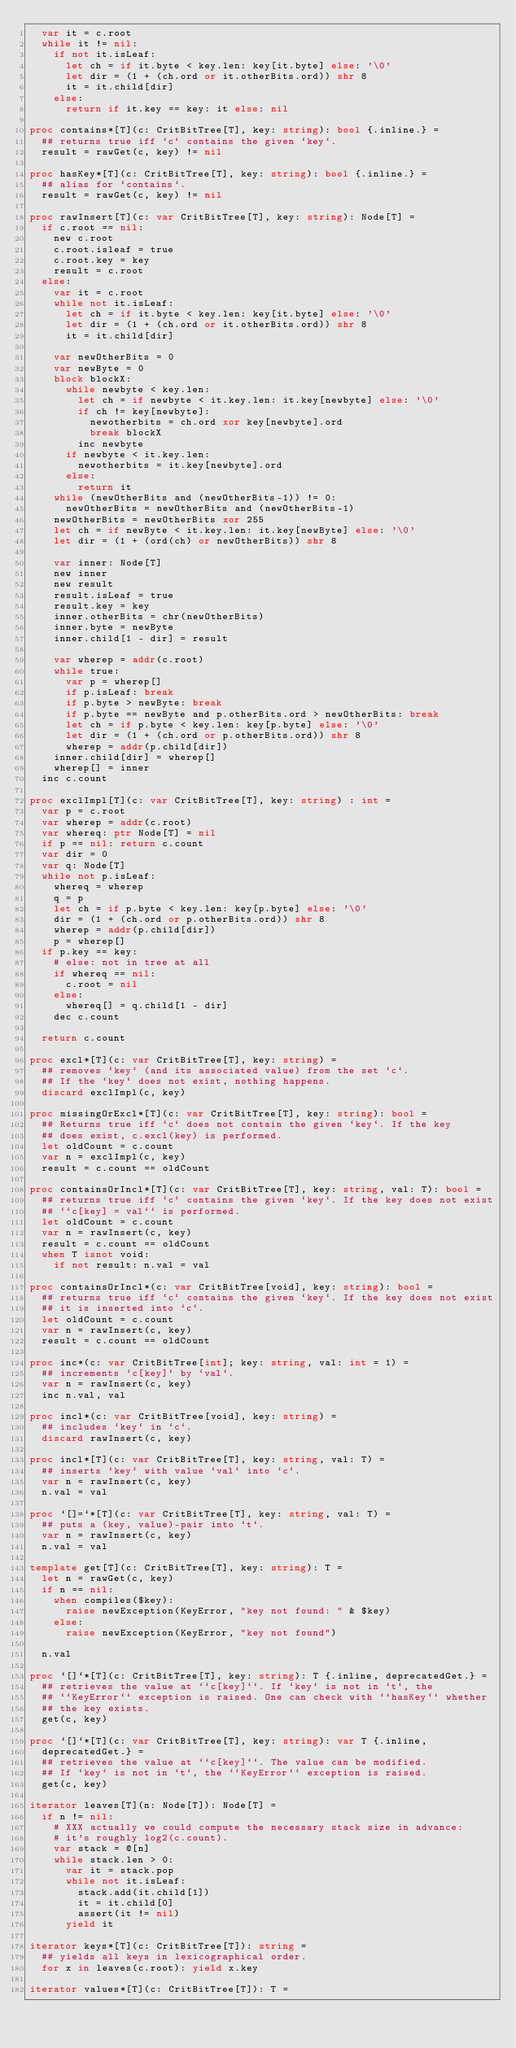<code> <loc_0><loc_0><loc_500><loc_500><_Nim_>  var it = c.root
  while it != nil:
    if not it.isLeaf:
      let ch = if it.byte < key.len: key[it.byte] else: '\0'
      let dir = (1 + (ch.ord or it.otherBits.ord)) shr 8
      it = it.child[dir]
    else:
      return if it.key == key: it else: nil

proc contains*[T](c: CritBitTree[T], key: string): bool {.inline.} =
  ## returns true iff `c` contains the given `key`.
  result = rawGet(c, key) != nil

proc hasKey*[T](c: CritBitTree[T], key: string): bool {.inline.} =
  ## alias for `contains`.
  result = rawGet(c, key) != nil

proc rawInsert[T](c: var CritBitTree[T], key: string): Node[T] =
  if c.root == nil:
    new c.root
    c.root.isleaf = true
    c.root.key = key
    result = c.root
  else:
    var it = c.root
    while not it.isLeaf:
      let ch = if it.byte < key.len: key[it.byte] else: '\0'
      let dir = (1 + (ch.ord or it.otherBits.ord)) shr 8
      it = it.child[dir]

    var newOtherBits = 0
    var newByte = 0
    block blockX:
      while newbyte < key.len:
        let ch = if newbyte < it.key.len: it.key[newbyte] else: '\0'
        if ch != key[newbyte]:
          newotherbits = ch.ord xor key[newbyte].ord
          break blockX
        inc newbyte
      if newbyte < it.key.len:
        newotherbits = it.key[newbyte].ord
      else:
        return it
    while (newOtherBits and (newOtherBits-1)) != 0:
      newOtherBits = newOtherBits and (newOtherBits-1)
    newOtherBits = newOtherBits xor 255
    let ch = if newByte < it.key.len: it.key[newByte] else: '\0'
    let dir = (1 + (ord(ch) or newOtherBits)) shr 8

    var inner: Node[T]
    new inner
    new result
    result.isLeaf = true
    result.key = key
    inner.otherBits = chr(newOtherBits)
    inner.byte = newByte
    inner.child[1 - dir] = result

    var wherep = addr(c.root)
    while true:
      var p = wherep[]
      if p.isLeaf: break
      if p.byte > newByte: break
      if p.byte == newByte and p.otherBits.ord > newOtherBits: break
      let ch = if p.byte < key.len: key[p.byte] else: '\0'
      let dir = (1 + (ch.ord or p.otherBits.ord)) shr 8
      wherep = addr(p.child[dir])
    inner.child[dir] = wherep[]
    wherep[] = inner
  inc c.count

proc exclImpl[T](c: var CritBitTree[T], key: string) : int =
  var p = c.root
  var wherep = addr(c.root)
  var whereq: ptr Node[T] = nil
  if p == nil: return c.count
  var dir = 0
  var q: Node[T]
  while not p.isLeaf:
    whereq = wherep
    q = p
    let ch = if p.byte < key.len: key[p.byte] else: '\0'
    dir = (1 + (ch.ord or p.otherBits.ord)) shr 8
    wherep = addr(p.child[dir])
    p = wherep[]
  if p.key == key:
    # else: not in tree at all
    if whereq == nil:
      c.root = nil
    else:
      whereq[] = q.child[1 - dir]
    dec c.count

  return c.count

proc excl*[T](c: var CritBitTree[T], key: string) =
  ## removes `key` (and its associated value) from the set `c`.
  ## If the `key` does not exist, nothing happens.
  discard exclImpl(c, key)

proc missingOrExcl*[T](c: var CritBitTree[T], key: string): bool =
  ## Returns true iff `c` does not contain the given `key`. If the key
  ## does exist, c.excl(key) is performed.
  let oldCount = c.count
  var n = exclImpl(c, key)
  result = c.count == oldCount

proc containsOrIncl*[T](c: var CritBitTree[T], key: string, val: T): bool =
  ## returns true iff `c` contains the given `key`. If the key does not exist
  ## ``c[key] = val`` is performed.
  let oldCount = c.count
  var n = rawInsert(c, key)
  result = c.count == oldCount
  when T isnot void:
    if not result: n.val = val

proc containsOrIncl*(c: var CritBitTree[void], key: string): bool =
  ## returns true iff `c` contains the given `key`. If the key does not exist
  ## it is inserted into `c`.
  let oldCount = c.count
  var n = rawInsert(c, key)
  result = c.count == oldCount

proc inc*(c: var CritBitTree[int]; key: string, val: int = 1) =
  ## increments `c[key]` by `val`.
  var n = rawInsert(c, key)
  inc n.val, val

proc incl*(c: var CritBitTree[void], key: string) =
  ## includes `key` in `c`.
  discard rawInsert(c, key)

proc incl*[T](c: var CritBitTree[T], key: string, val: T) =
  ## inserts `key` with value `val` into `c`.
  var n = rawInsert(c, key)
  n.val = val

proc `[]=`*[T](c: var CritBitTree[T], key: string, val: T) =
  ## puts a (key, value)-pair into `t`.
  var n = rawInsert(c, key)
  n.val = val

template get[T](c: CritBitTree[T], key: string): T =
  let n = rawGet(c, key)
  if n == nil:
    when compiles($key):
      raise newException(KeyError, "key not found: " & $key)
    else:
      raise newException(KeyError, "key not found")

  n.val

proc `[]`*[T](c: CritBitTree[T], key: string): T {.inline, deprecatedGet.} =
  ## retrieves the value at ``c[key]``. If `key` is not in `t`, the
  ## ``KeyError`` exception is raised. One can check with ``hasKey`` whether
  ## the key exists.
  get(c, key)

proc `[]`*[T](c: var CritBitTree[T], key: string): var T {.inline,
  deprecatedGet.} =
  ## retrieves the value at ``c[key]``. The value can be modified.
  ## If `key` is not in `t`, the ``KeyError`` exception is raised.
  get(c, key)

iterator leaves[T](n: Node[T]): Node[T] =
  if n != nil:
    # XXX actually we could compute the necessary stack size in advance:
    # it's roughly log2(c.count).
    var stack = @[n]
    while stack.len > 0:
      var it = stack.pop
      while not it.isLeaf:
        stack.add(it.child[1])
        it = it.child[0]
        assert(it != nil)
      yield it

iterator keys*[T](c: CritBitTree[T]): string =
  ## yields all keys in lexicographical order.
  for x in leaves(c.root): yield x.key

iterator values*[T](c: CritBitTree[T]): T =</code> 